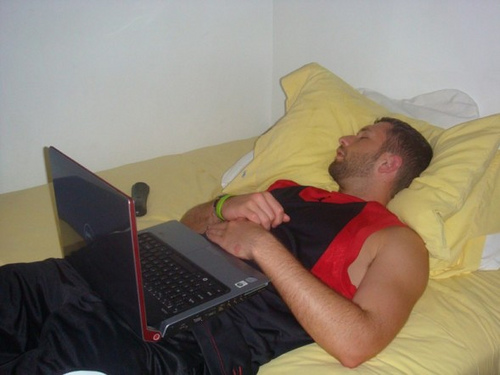Imagine a backstory for the scene depicted in the image. John, a college student, had a long day filled with lectures and sports practice. After returning home, he decided to catch up on some pending assignments and check his emails on his laptop. Exhausted from the day's activities, he barely managed to change into comfortable clothing before collapsing onto his bed. While browsing through a few videos for his research project, lethargy took over, and he drifted off to sleep. The remote control beside him suggests he might have planned to watch a movie or his favorite series later that evening. The scene encapsulates a typical end-of-day routine filled with productivity, entertainment, and subsequent rest. If this scene were the opening of a novel, how would the first paragraph read? In the dim glow of the early evening, John lay sprawled on his bed, a picture of serene exhaustion. His laptop, still humming softly, rested precariously on his lap, a testament to his dedication and the strenuous day that had left him utterly drained. The remote control sat within arm's reach, hinting at plans of unwinding that were never realized. Dressed in a simple black and red sports jersey, his muscular form stretched across the bed, enveloped by the comforting embrace of his yellow sheets and pillows. The quiet room, tinged with the soft hum of electronics, bore silent witness to a fleeting pause in the ceaseless rhythm of his life. 